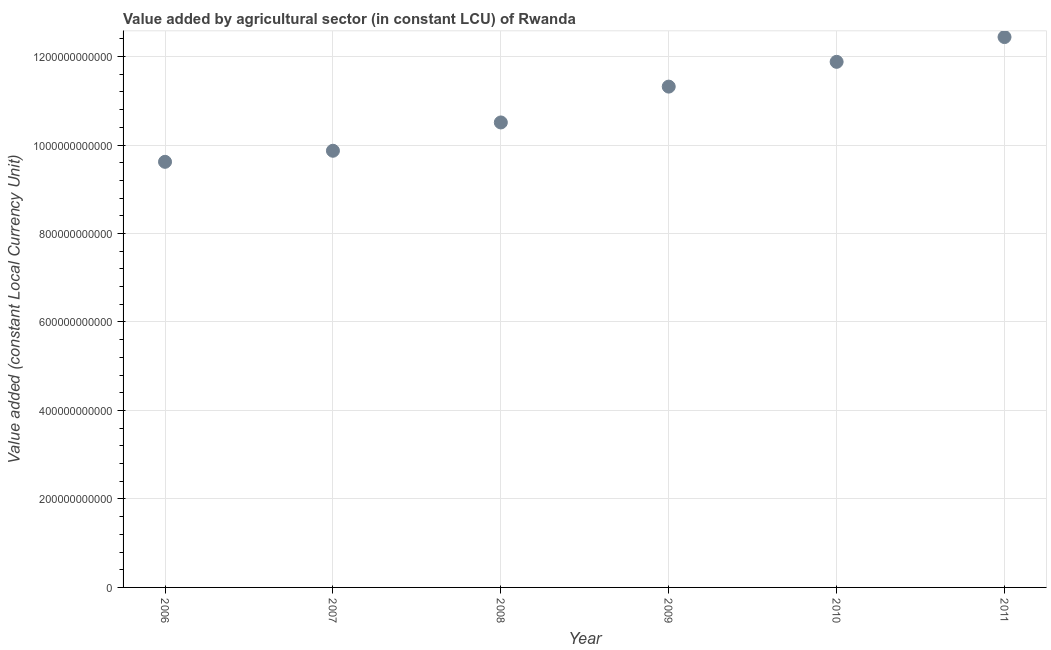What is the value added by agriculture sector in 2009?
Keep it short and to the point. 1.13e+12. Across all years, what is the maximum value added by agriculture sector?
Provide a short and direct response. 1.24e+12. Across all years, what is the minimum value added by agriculture sector?
Your response must be concise. 9.62e+11. In which year was the value added by agriculture sector minimum?
Your answer should be very brief. 2006. What is the sum of the value added by agriculture sector?
Offer a very short reply. 6.56e+12. What is the difference between the value added by agriculture sector in 2006 and 2011?
Your answer should be very brief. -2.82e+11. What is the average value added by agriculture sector per year?
Your answer should be very brief. 1.09e+12. What is the median value added by agriculture sector?
Offer a terse response. 1.09e+12. In how many years, is the value added by agriculture sector greater than 440000000000 LCU?
Provide a succinct answer. 6. What is the ratio of the value added by agriculture sector in 2006 to that in 2008?
Offer a terse response. 0.92. What is the difference between the highest and the second highest value added by agriculture sector?
Provide a short and direct response. 5.60e+1. What is the difference between the highest and the lowest value added by agriculture sector?
Provide a succinct answer. 2.82e+11. What is the difference between two consecutive major ticks on the Y-axis?
Offer a terse response. 2.00e+11. What is the title of the graph?
Offer a very short reply. Value added by agricultural sector (in constant LCU) of Rwanda. What is the label or title of the X-axis?
Your answer should be very brief. Year. What is the label or title of the Y-axis?
Keep it short and to the point. Value added (constant Local Currency Unit). What is the Value added (constant Local Currency Unit) in 2006?
Keep it short and to the point. 9.62e+11. What is the Value added (constant Local Currency Unit) in 2007?
Your answer should be compact. 9.87e+11. What is the Value added (constant Local Currency Unit) in 2008?
Keep it short and to the point. 1.05e+12. What is the Value added (constant Local Currency Unit) in 2009?
Ensure brevity in your answer.  1.13e+12. What is the Value added (constant Local Currency Unit) in 2010?
Ensure brevity in your answer.  1.19e+12. What is the Value added (constant Local Currency Unit) in 2011?
Your answer should be compact. 1.24e+12. What is the difference between the Value added (constant Local Currency Unit) in 2006 and 2007?
Give a very brief answer. -2.50e+1. What is the difference between the Value added (constant Local Currency Unit) in 2006 and 2008?
Give a very brief answer. -8.90e+1. What is the difference between the Value added (constant Local Currency Unit) in 2006 and 2009?
Keep it short and to the point. -1.70e+11. What is the difference between the Value added (constant Local Currency Unit) in 2006 and 2010?
Provide a short and direct response. -2.26e+11. What is the difference between the Value added (constant Local Currency Unit) in 2006 and 2011?
Your answer should be very brief. -2.82e+11. What is the difference between the Value added (constant Local Currency Unit) in 2007 and 2008?
Keep it short and to the point. -6.40e+1. What is the difference between the Value added (constant Local Currency Unit) in 2007 and 2009?
Offer a very short reply. -1.45e+11. What is the difference between the Value added (constant Local Currency Unit) in 2007 and 2010?
Your answer should be compact. -2.01e+11. What is the difference between the Value added (constant Local Currency Unit) in 2007 and 2011?
Provide a short and direct response. -2.57e+11. What is the difference between the Value added (constant Local Currency Unit) in 2008 and 2009?
Ensure brevity in your answer.  -8.10e+1. What is the difference between the Value added (constant Local Currency Unit) in 2008 and 2010?
Provide a short and direct response. -1.37e+11. What is the difference between the Value added (constant Local Currency Unit) in 2008 and 2011?
Provide a succinct answer. -1.93e+11. What is the difference between the Value added (constant Local Currency Unit) in 2009 and 2010?
Your answer should be very brief. -5.60e+1. What is the difference between the Value added (constant Local Currency Unit) in 2009 and 2011?
Your response must be concise. -1.12e+11. What is the difference between the Value added (constant Local Currency Unit) in 2010 and 2011?
Give a very brief answer. -5.60e+1. What is the ratio of the Value added (constant Local Currency Unit) in 2006 to that in 2007?
Offer a terse response. 0.97. What is the ratio of the Value added (constant Local Currency Unit) in 2006 to that in 2008?
Provide a succinct answer. 0.92. What is the ratio of the Value added (constant Local Currency Unit) in 2006 to that in 2010?
Provide a short and direct response. 0.81. What is the ratio of the Value added (constant Local Currency Unit) in 2006 to that in 2011?
Provide a succinct answer. 0.77. What is the ratio of the Value added (constant Local Currency Unit) in 2007 to that in 2008?
Offer a terse response. 0.94. What is the ratio of the Value added (constant Local Currency Unit) in 2007 to that in 2009?
Give a very brief answer. 0.87. What is the ratio of the Value added (constant Local Currency Unit) in 2007 to that in 2010?
Offer a very short reply. 0.83. What is the ratio of the Value added (constant Local Currency Unit) in 2007 to that in 2011?
Keep it short and to the point. 0.79. What is the ratio of the Value added (constant Local Currency Unit) in 2008 to that in 2009?
Make the answer very short. 0.93. What is the ratio of the Value added (constant Local Currency Unit) in 2008 to that in 2010?
Keep it short and to the point. 0.89. What is the ratio of the Value added (constant Local Currency Unit) in 2008 to that in 2011?
Offer a very short reply. 0.84. What is the ratio of the Value added (constant Local Currency Unit) in 2009 to that in 2010?
Your answer should be very brief. 0.95. What is the ratio of the Value added (constant Local Currency Unit) in 2009 to that in 2011?
Provide a short and direct response. 0.91. What is the ratio of the Value added (constant Local Currency Unit) in 2010 to that in 2011?
Give a very brief answer. 0.95. 